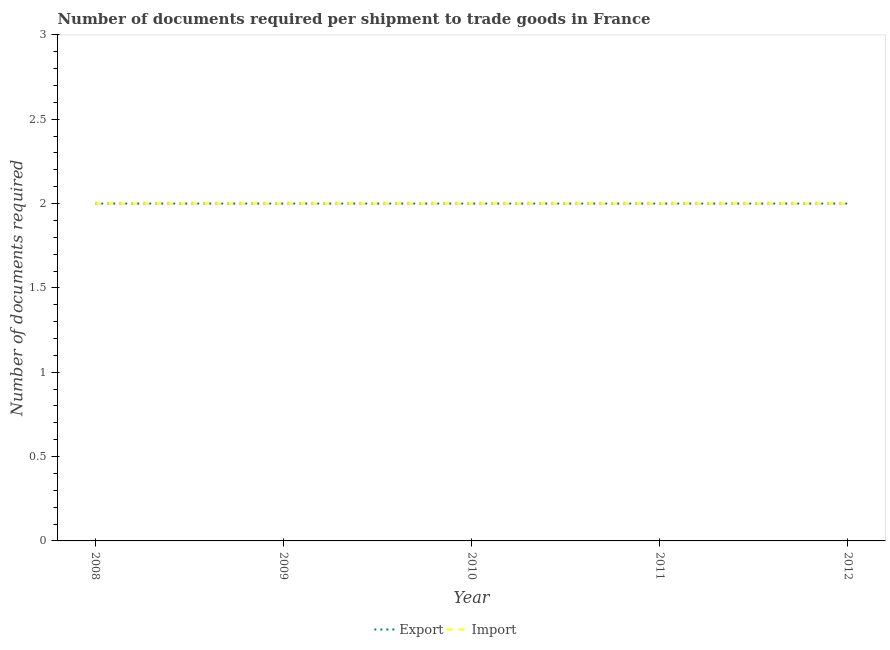How many different coloured lines are there?
Your answer should be compact. 2. Does the line corresponding to number of documents required to export goods intersect with the line corresponding to number of documents required to import goods?
Give a very brief answer. Yes. Is the number of lines equal to the number of legend labels?
Make the answer very short. Yes. What is the number of documents required to export goods in 2008?
Offer a very short reply. 2. Across all years, what is the maximum number of documents required to export goods?
Keep it short and to the point. 2. Across all years, what is the minimum number of documents required to import goods?
Your response must be concise. 2. What is the total number of documents required to export goods in the graph?
Offer a terse response. 10. What is the difference between the number of documents required to export goods in 2008 and that in 2012?
Provide a succinct answer. 0. What is the ratio of the number of documents required to export goods in 2010 to that in 2012?
Your response must be concise. 1. In how many years, is the number of documents required to export goods greater than the average number of documents required to export goods taken over all years?
Ensure brevity in your answer.  0. Is the sum of the number of documents required to import goods in 2008 and 2012 greater than the maximum number of documents required to export goods across all years?
Ensure brevity in your answer.  Yes. Is the number of documents required to import goods strictly greater than the number of documents required to export goods over the years?
Ensure brevity in your answer.  No. Is the number of documents required to import goods strictly less than the number of documents required to export goods over the years?
Your answer should be very brief. No. How many years are there in the graph?
Offer a terse response. 5. What is the difference between two consecutive major ticks on the Y-axis?
Give a very brief answer. 0.5. Are the values on the major ticks of Y-axis written in scientific E-notation?
Your answer should be very brief. No. Does the graph contain grids?
Ensure brevity in your answer.  No. Where does the legend appear in the graph?
Make the answer very short. Bottom center. How many legend labels are there?
Make the answer very short. 2. What is the title of the graph?
Keep it short and to the point. Number of documents required per shipment to trade goods in France. What is the label or title of the X-axis?
Offer a terse response. Year. What is the label or title of the Y-axis?
Give a very brief answer. Number of documents required. What is the Number of documents required in Import in 2009?
Keep it short and to the point. 2. What is the Number of documents required of Export in 2011?
Offer a terse response. 2. What is the Number of documents required of Import in 2011?
Provide a succinct answer. 2. What is the Number of documents required of Import in 2012?
Provide a succinct answer. 2. Across all years, what is the maximum Number of documents required in Export?
Make the answer very short. 2. Across all years, what is the maximum Number of documents required of Import?
Your answer should be compact. 2. Across all years, what is the minimum Number of documents required in Export?
Your answer should be very brief. 2. What is the total Number of documents required of Export in the graph?
Offer a terse response. 10. What is the total Number of documents required in Import in the graph?
Provide a succinct answer. 10. What is the difference between the Number of documents required of Import in 2008 and that in 2009?
Your response must be concise. 0. What is the difference between the Number of documents required in Export in 2008 and that in 2010?
Keep it short and to the point. 0. What is the difference between the Number of documents required in Export in 2008 and that in 2012?
Make the answer very short. 0. What is the difference between the Number of documents required in Export in 2009 and that in 2010?
Keep it short and to the point. 0. What is the difference between the Number of documents required of Import in 2009 and that in 2011?
Offer a terse response. 0. What is the difference between the Number of documents required in Import in 2010 and that in 2011?
Ensure brevity in your answer.  0. What is the difference between the Number of documents required of Export in 2010 and that in 2012?
Give a very brief answer. 0. What is the difference between the Number of documents required in Export in 2011 and that in 2012?
Keep it short and to the point. 0. What is the difference between the Number of documents required in Import in 2011 and that in 2012?
Give a very brief answer. 0. What is the difference between the Number of documents required in Export in 2008 and the Number of documents required in Import in 2010?
Keep it short and to the point. 0. What is the difference between the Number of documents required of Export in 2008 and the Number of documents required of Import in 2011?
Your response must be concise. 0. What is the difference between the Number of documents required in Export in 2008 and the Number of documents required in Import in 2012?
Offer a terse response. 0. What is the difference between the Number of documents required in Export in 2009 and the Number of documents required in Import in 2012?
Offer a terse response. 0. What is the difference between the Number of documents required in Export in 2010 and the Number of documents required in Import in 2012?
Your answer should be compact. 0. What is the difference between the Number of documents required in Export in 2011 and the Number of documents required in Import in 2012?
Your answer should be compact. 0. What is the average Number of documents required of Import per year?
Offer a very short reply. 2. In the year 2009, what is the difference between the Number of documents required in Export and Number of documents required in Import?
Give a very brief answer. 0. In the year 2011, what is the difference between the Number of documents required of Export and Number of documents required of Import?
Your response must be concise. 0. In the year 2012, what is the difference between the Number of documents required of Export and Number of documents required of Import?
Provide a succinct answer. 0. What is the ratio of the Number of documents required of Export in 2008 to that in 2009?
Provide a succinct answer. 1. What is the ratio of the Number of documents required of Import in 2008 to that in 2009?
Make the answer very short. 1. What is the ratio of the Number of documents required of Export in 2008 to that in 2011?
Ensure brevity in your answer.  1. What is the ratio of the Number of documents required of Export in 2008 to that in 2012?
Offer a very short reply. 1. What is the ratio of the Number of documents required in Import in 2008 to that in 2012?
Your answer should be compact. 1. What is the ratio of the Number of documents required of Import in 2009 to that in 2010?
Provide a succinct answer. 1. What is the ratio of the Number of documents required in Export in 2009 to that in 2011?
Your response must be concise. 1. What is the ratio of the Number of documents required in Import in 2010 to that in 2012?
Your answer should be compact. 1. What is the ratio of the Number of documents required in Import in 2011 to that in 2012?
Keep it short and to the point. 1. What is the difference between the highest and the second highest Number of documents required of Export?
Your response must be concise. 0. What is the difference between the highest and the lowest Number of documents required of Export?
Provide a succinct answer. 0. What is the difference between the highest and the lowest Number of documents required of Import?
Ensure brevity in your answer.  0. 